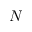Convert formula to latex. <formula><loc_0><loc_0><loc_500><loc_500>N</formula> 